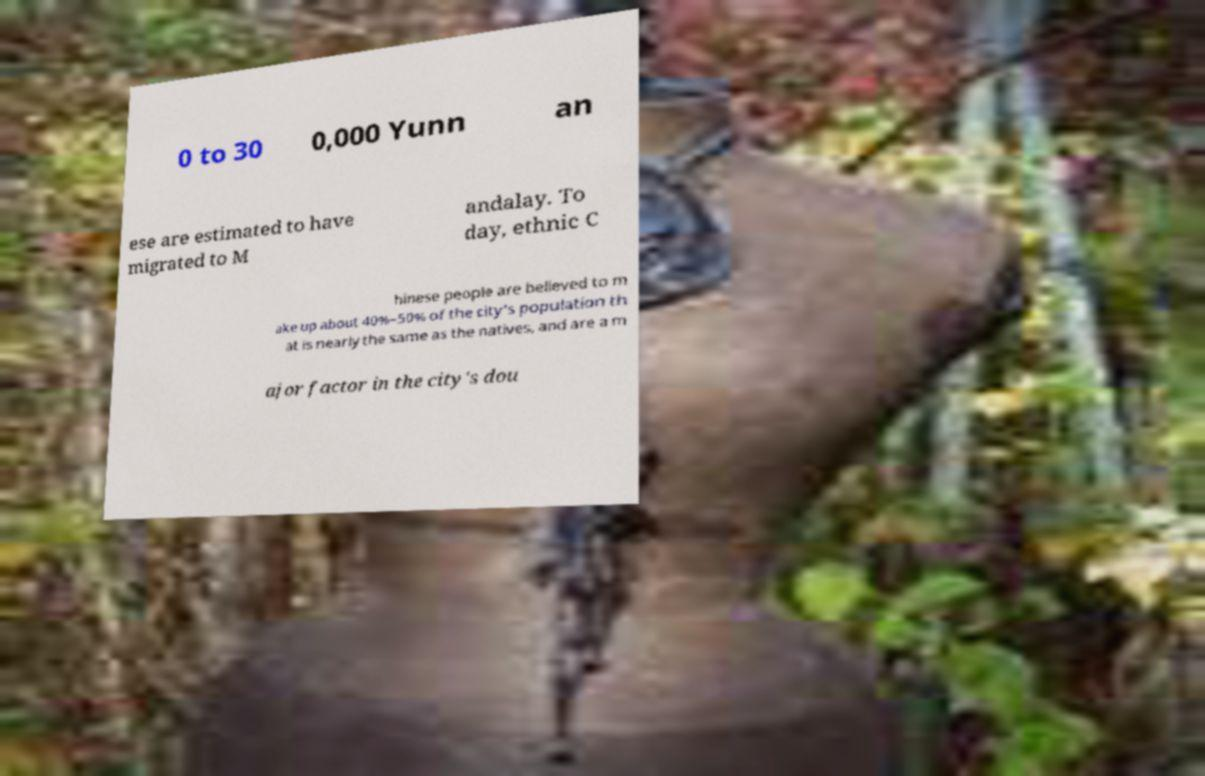Could you extract and type out the text from this image? 0 to 30 0,000 Yunn an ese are estimated to have migrated to M andalay. To day, ethnic C hinese people are believed to m ake up about 40%–50% of the city's population th at is nearly the same as the natives, and are a m ajor factor in the city's dou 